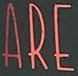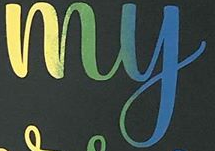Read the text from these images in sequence, separated by a semicolon. ARE; my 